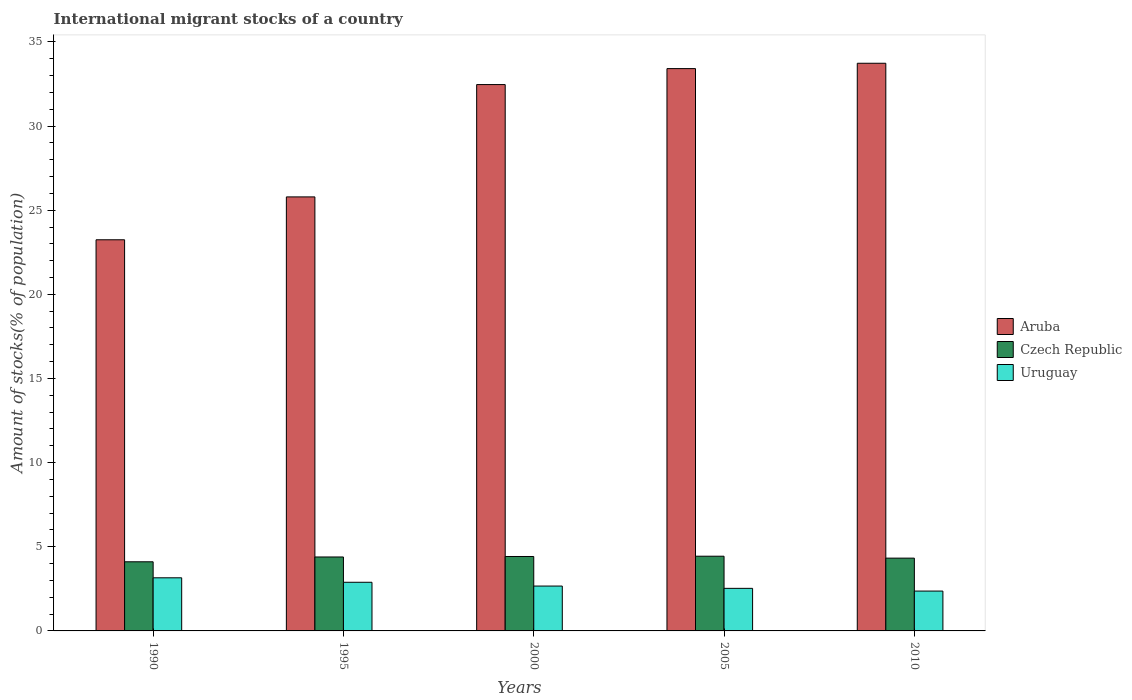How many different coloured bars are there?
Your answer should be compact. 3. Are the number of bars on each tick of the X-axis equal?
Provide a short and direct response. Yes. How many bars are there on the 5th tick from the right?
Your answer should be very brief. 3. In how many cases, is the number of bars for a given year not equal to the number of legend labels?
Your response must be concise. 0. What is the amount of stocks in in Aruba in 1990?
Ensure brevity in your answer.  23.24. Across all years, what is the maximum amount of stocks in in Uruguay?
Offer a very short reply. 3.16. Across all years, what is the minimum amount of stocks in in Aruba?
Offer a very short reply. 23.24. In which year was the amount of stocks in in Aruba maximum?
Keep it short and to the point. 2010. In which year was the amount of stocks in in Czech Republic minimum?
Your answer should be compact. 1990. What is the total amount of stocks in in Czech Republic in the graph?
Make the answer very short. 21.69. What is the difference between the amount of stocks in in Aruba in 1990 and that in 2010?
Keep it short and to the point. -10.49. What is the difference between the amount of stocks in in Czech Republic in 2005 and the amount of stocks in in Aruba in 1990?
Provide a succinct answer. -18.8. What is the average amount of stocks in in Aruba per year?
Make the answer very short. 29.73. In the year 1990, what is the difference between the amount of stocks in in Czech Republic and amount of stocks in in Uruguay?
Make the answer very short. 0.95. What is the ratio of the amount of stocks in in Uruguay in 1995 to that in 2000?
Keep it short and to the point. 1.08. Is the amount of stocks in in Uruguay in 1990 less than that in 2005?
Your answer should be very brief. No. What is the difference between the highest and the second highest amount of stocks in in Czech Republic?
Your response must be concise. 0.02. What is the difference between the highest and the lowest amount of stocks in in Aruba?
Offer a terse response. 10.49. In how many years, is the amount of stocks in in Czech Republic greater than the average amount of stocks in in Czech Republic taken over all years?
Your answer should be compact. 3. Is the sum of the amount of stocks in in Aruba in 2000 and 2010 greater than the maximum amount of stocks in in Uruguay across all years?
Your answer should be very brief. Yes. What does the 3rd bar from the left in 2000 represents?
Your answer should be compact. Uruguay. What does the 2nd bar from the right in 2010 represents?
Give a very brief answer. Czech Republic. How many bars are there?
Your answer should be compact. 15. Are all the bars in the graph horizontal?
Provide a succinct answer. No. How many years are there in the graph?
Your response must be concise. 5. Are the values on the major ticks of Y-axis written in scientific E-notation?
Provide a succinct answer. No. Does the graph contain any zero values?
Provide a succinct answer. No. Where does the legend appear in the graph?
Provide a short and direct response. Center right. What is the title of the graph?
Your answer should be very brief. International migrant stocks of a country. Does "Isle of Man" appear as one of the legend labels in the graph?
Ensure brevity in your answer.  No. What is the label or title of the X-axis?
Provide a short and direct response. Years. What is the label or title of the Y-axis?
Provide a succinct answer. Amount of stocks(% of population). What is the Amount of stocks(% of population) in Aruba in 1990?
Your response must be concise. 23.24. What is the Amount of stocks(% of population) in Czech Republic in 1990?
Your response must be concise. 4.11. What is the Amount of stocks(% of population) of Uruguay in 1990?
Make the answer very short. 3.16. What is the Amount of stocks(% of population) of Aruba in 1995?
Ensure brevity in your answer.  25.79. What is the Amount of stocks(% of population) of Czech Republic in 1995?
Make the answer very short. 4.39. What is the Amount of stocks(% of population) of Uruguay in 1995?
Your response must be concise. 2.89. What is the Amount of stocks(% of population) of Aruba in 2000?
Your response must be concise. 32.46. What is the Amount of stocks(% of population) of Czech Republic in 2000?
Your answer should be very brief. 4.42. What is the Amount of stocks(% of population) of Uruguay in 2000?
Give a very brief answer. 2.67. What is the Amount of stocks(% of population) in Aruba in 2005?
Give a very brief answer. 33.41. What is the Amount of stocks(% of population) of Czech Republic in 2005?
Your response must be concise. 4.44. What is the Amount of stocks(% of population) of Uruguay in 2005?
Offer a very short reply. 2.53. What is the Amount of stocks(% of population) of Aruba in 2010?
Your answer should be very brief. 33.73. What is the Amount of stocks(% of population) of Czech Republic in 2010?
Ensure brevity in your answer.  4.33. What is the Amount of stocks(% of population) in Uruguay in 2010?
Your answer should be compact. 2.37. Across all years, what is the maximum Amount of stocks(% of population) of Aruba?
Keep it short and to the point. 33.73. Across all years, what is the maximum Amount of stocks(% of population) in Czech Republic?
Provide a short and direct response. 4.44. Across all years, what is the maximum Amount of stocks(% of population) of Uruguay?
Give a very brief answer. 3.16. Across all years, what is the minimum Amount of stocks(% of population) in Aruba?
Provide a short and direct response. 23.24. Across all years, what is the minimum Amount of stocks(% of population) in Czech Republic?
Provide a succinct answer. 4.11. Across all years, what is the minimum Amount of stocks(% of population) of Uruguay?
Provide a short and direct response. 2.37. What is the total Amount of stocks(% of population) of Aruba in the graph?
Provide a succinct answer. 148.63. What is the total Amount of stocks(% of population) in Czech Republic in the graph?
Keep it short and to the point. 21.69. What is the total Amount of stocks(% of population) of Uruguay in the graph?
Offer a terse response. 13.61. What is the difference between the Amount of stocks(% of population) in Aruba in 1990 and that in 1995?
Offer a terse response. -2.55. What is the difference between the Amount of stocks(% of population) of Czech Republic in 1990 and that in 1995?
Provide a succinct answer. -0.29. What is the difference between the Amount of stocks(% of population) of Uruguay in 1990 and that in 1995?
Your answer should be very brief. 0.27. What is the difference between the Amount of stocks(% of population) of Aruba in 1990 and that in 2000?
Your response must be concise. -9.22. What is the difference between the Amount of stocks(% of population) of Czech Republic in 1990 and that in 2000?
Provide a short and direct response. -0.31. What is the difference between the Amount of stocks(% of population) of Uruguay in 1990 and that in 2000?
Make the answer very short. 0.49. What is the difference between the Amount of stocks(% of population) of Aruba in 1990 and that in 2005?
Offer a very short reply. -10.17. What is the difference between the Amount of stocks(% of population) of Czech Republic in 1990 and that in 2005?
Provide a short and direct response. -0.33. What is the difference between the Amount of stocks(% of population) in Uruguay in 1990 and that in 2005?
Offer a terse response. 0.63. What is the difference between the Amount of stocks(% of population) of Aruba in 1990 and that in 2010?
Keep it short and to the point. -10.49. What is the difference between the Amount of stocks(% of population) in Czech Republic in 1990 and that in 2010?
Keep it short and to the point. -0.22. What is the difference between the Amount of stocks(% of population) of Uruguay in 1990 and that in 2010?
Your answer should be compact. 0.79. What is the difference between the Amount of stocks(% of population) in Aruba in 1995 and that in 2000?
Provide a short and direct response. -6.67. What is the difference between the Amount of stocks(% of population) in Czech Republic in 1995 and that in 2000?
Keep it short and to the point. -0.03. What is the difference between the Amount of stocks(% of population) in Uruguay in 1995 and that in 2000?
Provide a short and direct response. 0.22. What is the difference between the Amount of stocks(% of population) in Aruba in 1995 and that in 2005?
Your answer should be compact. -7.62. What is the difference between the Amount of stocks(% of population) in Czech Republic in 1995 and that in 2005?
Your answer should be very brief. -0.05. What is the difference between the Amount of stocks(% of population) of Uruguay in 1995 and that in 2005?
Offer a terse response. 0.36. What is the difference between the Amount of stocks(% of population) in Aruba in 1995 and that in 2010?
Offer a terse response. -7.94. What is the difference between the Amount of stocks(% of population) in Czech Republic in 1995 and that in 2010?
Provide a short and direct response. 0.07. What is the difference between the Amount of stocks(% of population) in Uruguay in 1995 and that in 2010?
Provide a short and direct response. 0.52. What is the difference between the Amount of stocks(% of population) of Aruba in 2000 and that in 2005?
Keep it short and to the point. -0.95. What is the difference between the Amount of stocks(% of population) in Czech Republic in 2000 and that in 2005?
Provide a succinct answer. -0.02. What is the difference between the Amount of stocks(% of population) in Uruguay in 2000 and that in 2005?
Make the answer very short. 0.14. What is the difference between the Amount of stocks(% of population) of Aruba in 2000 and that in 2010?
Offer a very short reply. -1.27. What is the difference between the Amount of stocks(% of population) in Czech Republic in 2000 and that in 2010?
Give a very brief answer. 0.1. What is the difference between the Amount of stocks(% of population) in Uruguay in 2000 and that in 2010?
Provide a short and direct response. 0.3. What is the difference between the Amount of stocks(% of population) in Aruba in 2005 and that in 2010?
Make the answer very short. -0.32. What is the difference between the Amount of stocks(% of population) of Czech Republic in 2005 and that in 2010?
Your answer should be compact. 0.11. What is the difference between the Amount of stocks(% of population) of Uruguay in 2005 and that in 2010?
Keep it short and to the point. 0.16. What is the difference between the Amount of stocks(% of population) in Aruba in 1990 and the Amount of stocks(% of population) in Czech Republic in 1995?
Provide a succinct answer. 18.85. What is the difference between the Amount of stocks(% of population) of Aruba in 1990 and the Amount of stocks(% of population) of Uruguay in 1995?
Ensure brevity in your answer.  20.35. What is the difference between the Amount of stocks(% of population) of Czech Republic in 1990 and the Amount of stocks(% of population) of Uruguay in 1995?
Provide a succinct answer. 1.22. What is the difference between the Amount of stocks(% of population) of Aruba in 1990 and the Amount of stocks(% of population) of Czech Republic in 2000?
Provide a short and direct response. 18.82. What is the difference between the Amount of stocks(% of population) in Aruba in 1990 and the Amount of stocks(% of population) in Uruguay in 2000?
Offer a terse response. 20.57. What is the difference between the Amount of stocks(% of population) of Czech Republic in 1990 and the Amount of stocks(% of population) of Uruguay in 2000?
Your answer should be compact. 1.44. What is the difference between the Amount of stocks(% of population) of Aruba in 1990 and the Amount of stocks(% of population) of Czech Republic in 2005?
Your answer should be compact. 18.8. What is the difference between the Amount of stocks(% of population) of Aruba in 1990 and the Amount of stocks(% of population) of Uruguay in 2005?
Offer a terse response. 20.71. What is the difference between the Amount of stocks(% of population) of Czech Republic in 1990 and the Amount of stocks(% of population) of Uruguay in 2005?
Keep it short and to the point. 1.58. What is the difference between the Amount of stocks(% of population) of Aruba in 1990 and the Amount of stocks(% of population) of Czech Republic in 2010?
Make the answer very short. 18.92. What is the difference between the Amount of stocks(% of population) in Aruba in 1990 and the Amount of stocks(% of population) in Uruguay in 2010?
Keep it short and to the point. 20.87. What is the difference between the Amount of stocks(% of population) of Czech Republic in 1990 and the Amount of stocks(% of population) of Uruguay in 2010?
Your answer should be compact. 1.74. What is the difference between the Amount of stocks(% of population) in Aruba in 1995 and the Amount of stocks(% of population) in Czech Republic in 2000?
Your response must be concise. 21.37. What is the difference between the Amount of stocks(% of population) of Aruba in 1995 and the Amount of stocks(% of population) of Uruguay in 2000?
Ensure brevity in your answer.  23.12. What is the difference between the Amount of stocks(% of population) in Czech Republic in 1995 and the Amount of stocks(% of population) in Uruguay in 2000?
Your answer should be very brief. 1.73. What is the difference between the Amount of stocks(% of population) in Aruba in 1995 and the Amount of stocks(% of population) in Czech Republic in 2005?
Provide a short and direct response. 21.35. What is the difference between the Amount of stocks(% of population) of Aruba in 1995 and the Amount of stocks(% of population) of Uruguay in 2005?
Your response must be concise. 23.26. What is the difference between the Amount of stocks(% of population) in Czech Republic in 1995 and the Amount of stocks(% of population) in Uruguay in 2005?
Provide a short and direct response. 1.86. What is the difference between the Amount of stocks(% of population) of Aruba in 1995 and the Amount of stocks(% of population) of Czech Republic in 2010?
Ensure brevity in your answer.  21.46. What is the difference between the Amount of stocks(% of population) of Aruba in 1995 and the Amount of stocks(% of population) of Uruguay in 2010?
Offer a very short reply. 23.42. What is the difference between the Amount of stocks(% of population) of Czech Republic in 1995 and the Amount of stocks(% of population) of Uruguay in 2010?
Provide a short and direct response. 2.03. What is the difference between the Amount of stocks(% of population) of Aruba in 2000 and the Amount of stocks(% of population) of Czech Republic in 2005?
Ensure brevity in your answer.  28.02. What is the difference between the Amount of stocks(% of population) of Aruba in 2000 and the Amount of stocks(% of population) of Uruguay in 2005?
Offer a very short reply. 29.93. What is the difference between the Amount of stocks(% of population) in Czech Republic in 2000 and the Amount of stocks(% of population) in Uruguay in 2005?
Give a very brief answer. 1.89. What is the difference between the Amount of stocks(% of population) in Aruba in 2000 and the Amount of stocks(% of population) in Czech Republic in 2010?
Your answer should be very brief. 28.14. What is the difference between the Amount of stocks(% of population) of Aruba in 2000 and the Amount of stocks(% of population) of Uruguay in 2010?
Your answer should be compact. 30.09. What is the difference between the Amount of stocks(% of population) in Czech Republic in 2000 and the Amount of stocks(% of population) in Uruguay in 2010?
Provide a succinct answer. 2.05. What is the difference between the Amount of stocks(% of population) of Aruba in 2005 and the Amount of stocks(% of population) of Czech Republic in 2010?
Your response must be concise. 29.09. What is the difference between the Amount of stocks(% of population) of Aruba in 2005 and the Amount of stocks(% of population) of Uruguay in 2010?
Provide a succinct answer. 31.04. What is the difference between the Amount of stocks(% of population) of Czech Republic in 2005 and the Amount of stocks(% of population) of Uruguay in 2010?
Provide a succinct answer. 2.07. What is the average Amount of stocks(% of population) in Aruba per year?
Offer a very short reply. 29.73. What is the average Amount of stocks(% of population) of Czech Republic per year?
Your answer should be very brief. 4.34. What is the average Amount of stocks(% of population) of Uruguay per year?
Make the answer very short. 2.72. In the year 1990, what is the difference between the Amount of stocks(% of population) in Aruba and Amount of stocks(% of population) in Czech Republic?
Keep it short and to the point. 19.13. In the year 1990, what is the difference between the Amount of stocks(% of population) in Aruba and Amount of stocks(% of population) in Uruguay?
Give a very brief answer. 20.09. In the year 1990, what is the difference between the Amount of stocks(% of population) of Czech Republic and Amount of stocks(% of population) of Uruguay?
Your response must be concise. 0.95. In the year 1995, what is the difference between the Amount of stocks(% of population) of Aruba and Amount of stocks(% of population) of Czech Republic?
Keep it short and to the point. 21.4. In the year 1995, what is the difference between the Amount of stocks(% of population) in Aruba and Amount of stocks(% of population) in Uruguay?
Offer a very short reply. 22.9. In the year 1995, what is the difference between the Amount of stocks(% of population) of Czech Republic and Amount of stocks(% of population) of Uruguay?
Give a very brief answer. 1.5. In the year 2000, what is the difference between the Amount of stocks(% of population) in Aruba and Amount of stocks(% of population) in Czech Republic?
Your answer should be very brief. 28.04. In the year 2000, what is the difference between the Amount of stocks(% of population) in Aruba and Amount of stocks(% of population) in Uruguay?
Your response must be concise. 29.8. In the year 2000, what is the difference between the Amount of stocks(% of population) of Czech Republic and Amount of stocks(% of population) of Uruguay?
Offer a terse response. 1.76. In the year 2005, what is the difference between the Amount of stocks(% of population) in Aruba and Amount of stocks(% of population) in Czech Republic?
Offer a terse response. 28.97. In the year 2005, what is the difference between the Amount of stocks(% of population) of Aruba and Amount of stocks(% of population) of Uruguay?
Keep it short and to the point. 30.88. In the year 2005, what is the difference between the Amount of stocks(% of population) in Czech Republic and Amount of stocks(% of population) in Uruguay?
Offer a terse response. 1.91. In the year 2010, what is the difference between the Amount of stocks(% of population) in Aruba and Amount of stocks(% of population) in Czech Republic?
Your answer should be very brief. 29.4. In the year 2010, what is the difference between the Amount of stocks(% of population) of Aruba and Amount of stocks(% of population) of Uruguay?
Keep it short and to the point. 31.36. In the year 2010, what is the difference between the Amount of stocks(% of population) in Czech Republic and Amount of stocks(% of population) in Uruguay?
Offer a very short reply. 1.96. What is the ratio of the Amount of stocks(% of population) in Aruba in 1990 to that in 1995?
Your answer should be compact. 0.9. What is the ratio of the Amount of stocks(% of population) in Czech Republic in 1990 to that in 1995?
Ensure brevity in your answer.  0.94. What is the ratio of the Amount of stocks(% of population) in Uruguay in 1990 to that in 1995?
Ensure brevity in your answer.  1.09. What is the ratio of the Amount of stocks(% of population) of Aruba in 1990 to that in 2000?
Your answer should be very brief. 0.72. What is the ratio of the Amount of stocks(% of population) of Czech Republic in 1990 to that in 2000?
Your response must be concise. 0.93. What is the ratio of the Amount of stocks(% of population) in Uruguay in 1990 to that in 2000?
Offer a terse response. 1.18. What is the ratio of the Amount of stocks(% of population) of Aruba in 1990 to that in 2005?
Offer a very short reply. 0.7. What is the ratio of the Amount of stocks(% of population) of Czech Republic in 1990 to that in 2005?
Make the answer very short. 0.93. What is the ratio of the Amount of stocks(% of population) of Uruguay in 1990 to that in 2005?
Offer a terse response. 1.25. What is the ratio of the Amount of stocks(% of population) of Aruba in 1990 to that in 2010?
Offer a terse response. 0.69. What is the ratio of the Amount of stocks(% of population) in Czech Republic in 1990 to that in 2010?
Give a very brief answer. 0.95. What is the ratio of the Amount of stocks(% of population) in Uruguay in 1990 to that in 2010?
Provide a short and direct response. 1.33. What is the ratio of the Amount of stocks(% of population) of Aruba in 1995 to that in 2000?
Give a very brief answer. 0.79. What is the ratio of the Amount of stocks(% of population) of Czech Republic in 1995 to that in 2000?
Your response must be concise. 0.99. What is the ratio of the Amount of stocks(% of population) in Uruguay in 1995 to that in 2000?
Provide a succinct answer. 1.08. What is the ratio of the Amount of stocks(% of population) of Aruba in 1995 to that in 2005?
Your response must be concise. 0.77. What is the ratio of the Amount of stocks(% of population) of Czech Republic in 1995 to that in 2005?
Make the answer very short. 0.99. What is the ratio of the Amount of stocks(% of population) in Uruguay in 1995 to that in 2005?
Your answer should be compact. 1.14. What is the ratio of the Amount of stocks(% of population) in Aruba in 1995 to that in 2010?
Your response must be concise. 0.76. What is the ratio of the Amount of stocks(% of population) of Czech Republic in 1995 to that in 2010?
Offer a terse response. 1.02. What is the ratio of the Amount of stocks(% of population) in Uruguay in 1995 to that in 2010?
Provide a short and direct response. 1.22. What is the ratio of the Amount of stocks(% of population) in Aruba in 2000 to that in 2005?
Provide a short and direct response. 0.97. What is the ratio of the Amount of stocks(% of population) of Czech Republic in 2000 to that in 2005?
Offer a very short reply. 1. What is the ratio of the Amount of stocks(% of population) in Uruguay in 2000 to that in 2005?
Offer a terse response. 1.05. What is the ratio of the Amount of stocks(% of population) in Aruba in 2000 to that in 2010?
Your response must be concise. 0.96. What is the ratio of the Amount of stocks(% of population) in Czech Republic in 2000 to that in 2010?
Keep it short and to the point. 1.02. What is the ratio of the Amount of stocks(% of population) in Uruguay in 2000 to that in 2010?
Provide a short and direct response. 1.13. What is the ratio of the Amount of stocks(% of population) in Aruba in 2005 to that in 2010?
Offer a very short reply. 0.99. What is the ratio of the Amount of stocks(% of population) in Czech Republic in 2005 to that in 2010?
Offer a very short reply. 1.03. What is the ratio of the Amount of stocks(% of population) in Uruguay in 2005 to that in 2010?
Your answer should be very brief. 1.07. What is the difference between the highest and the second highest Amount of stocks(% of population) in Aruba?
Provide a succinct answer. 0.32. What is the difference between the highest and the second highest Amount of stocks(% of population) of Czech Republic?
Offer a very short reply. 0.02. What is the difference between the highest and the second highest Amount of stocks(% of population) in Uruguay?
Offer a terse response. 0.27. What is the difference between the highest and the lowest Amount of stocks(% of population) of Aruba?
Your answer should be compact. 10.49. What is the difference between the highest and the lowest Amount of stocks(% of population) of Czech Republic?
Offer a very short reply. 0.33. What is the difference between the highest and the lowest Amount of stocks(% of population) in Uruguay?
Ensure brevity in your answer.  0.79. 